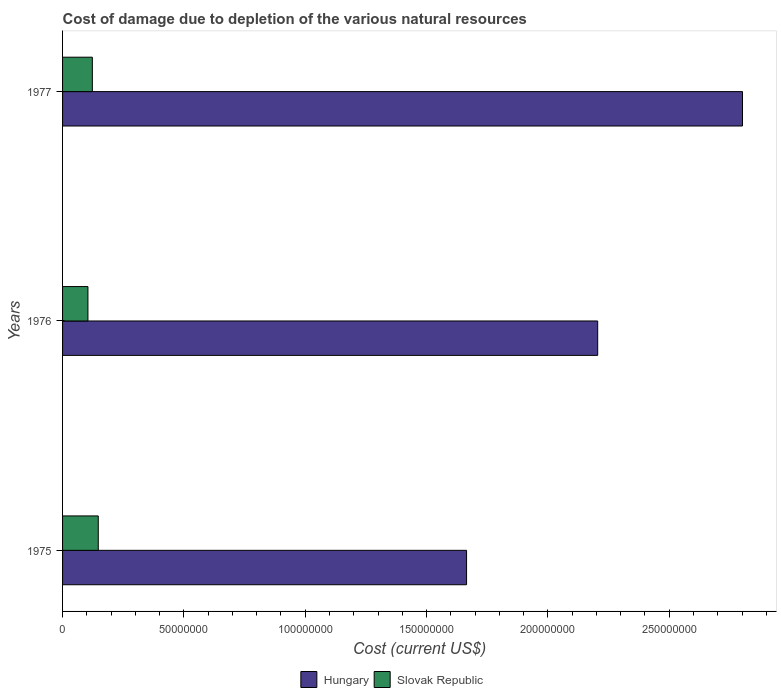How many different coloured bars are there?
Your answer should be very brief. 2. Are the number of bars on each tick of the Y-axis equal?
Keep it short and to the point. Yes. How many bars are there on the 3rd tick from the top?
Your answer should be compact. 2. How many bars are there on the 2nd tick from the bottom?
Keep it short and to the point. 2. What is the label of the 1st group of bars from the top?
Give a very brief answer. 1977. What is the cost of damage caused due to the depletion of various natural resources in Slovak Republic in 1976?
Give a very brief answer. 1.05e+07. Across all years, what is the maximum cost of damage caused due to the depletion of various natural resources in Slovak Republic?
Keep it short and to the point. 1.47e+07. Across all years, what is the minimum cost of damage caused due to the depletion of various natural resources in Hungary?
Your response must be concise. 1.66e+08. In which year was the cost of damage caused due to the depletion of various natural resources in Slovak Republic maximum?
Provide a short and direct response. 1975. In which year was the cost of damage caused due to the depletion of various natural resources in Hungary minimum?
Your answer should be compact. 1975. What is the total cost of damage caused due to the depletion of various natural resources in Slovak Republic in the graph?
Offer a terse response. 3.74e+07. What is the difference between the cost of damage caused due to the depletion of various natural resources in Slovak Republic in 1975 and that in 1976?
Keep it short and to the point. 4.25e+06. What is the difference between the cost of damage caused due to the depletion of various natural resources in Hungary in 1975 and the cost of damage caused due to the depletion of various natural resources in Slovak Republic in 1976?
Make the answer very short. 1.56e+08. What is the average cost of damage caused due to the depletion of various natural resources in Hungary per year?
Ensure brevity in your answer.  2.22e+08. In the year 1977, what is the difference between the cost of damage caused due to the depletion of various natural resources in Hungary and cost of damage caused due to the depletion of various natural resources in Slovak Republic?
Offer a terse response. 2.68e+08. In how many years, is the cost of damage caused due to the depletion of various natural resources in Hungary greater than 200000000 US$?
Your answer should be compact. 2. What is the ratio of the cost of damage caused due to the depletion of various natural resources in Hungary in 1975 to that in 1977?
Give a very brief answer. 0.59. Is the difference between the cost of damage caused due to the depletion of various natural resources in Hungary in 1975 and 1977 greater than the difference between the cost of damage caused due to the depletion of various natural resources in Slovak Republic in 1975 and 1977?
Ensure brevity in your answer.  No. What is the difference between the highest and the second highest cost of damage caused due to the depletion of various natural resources in Hungary?
Offer a very short reply. 5.97e+07. What is the difference between the highest and the lowest cost of damage caused due to the depletion of various natural resources in Hungary?
Offer a very short reply. 1.14e+08. In how many years, is the cost of damage caused due to the depletion of various natural resources in Slovak Republic greater than the average cost of damage caused due to the depletion of various natural resources in Slovak Republic taken over all years?
Give a very brief answer. 1. What does the 1st bar from the top in 1976 represents?
Make the answer very short. Slovak Republic. What does the 1st bar from the bottom in 1975 represents?
Give a very brief answer. Hungary. How many years are there in the graph?
Offer a terse response. 3. Are the values on the major ticks of X-axis written in scientific E-notation?
Ensure brevity in your answer.  No. How many legend labels are there?
Offer a terse response. 2. What is the title of the graph?
Keep it short and to the point. Cost of damage due to depletion of the various natural resources. What is the label or title of the X-axis?
Your response must be concise. Cost (current US$). What is the Cost (current US$) of Hungary in 1975?
Your answer should be very brief. 1.66e+08. What is the Cost (current US$) in Slovak Republic in 1975?
Offer a very short reply. 1.47e+07. What is the Cost (current US$) in Hungary in 1976?
Your response must be concise. 2.21e+08. What is the Cost (current US$) of Slovak Republic in 1976?
Give a very brief answer. 1.05e+07. What is the Cost (current US$) of Hungary in 1977?
Offer a terse response. 2.80e+08. What is the Cost (current US$) of Slovak Republic in 1977?
Provide a succinct answer. 1.23e+07. Across all years, what is the maximum Cost (current US$) in Hungary?
Your response must be concise. 2.80e+08. Across all years, what is the maximum Cost (current US$) in Slovak Republic?
Your response must be concise. 1.47e+07. Across all years, what is the minimum Cost (current US$) of Hungary?
Keep it short and to the point. 1.66e+08. Across all years, what is the minimum Cost (current US$) in Slovak Republic?
Keep it short and to the point. 1.05e+07. What is the total Cost (current US$) in Hungary in the graph?
Your answer should be very brief. 6.67e+08. What is the total Cost (current US$) of Slovak Republic in the graph?
Provide a short and direct response. 3.74e+07. What is the difference between the Cost (current US$) of Hungary in 1975 and that in 1976?
Keep it short and to the point. -5.40e+07. What is the difference between the Cost (current US$) of Slovak Republic in 1975 and that in 1976?
Provide a succinct answer. 4.25e+06. What is the difference between the Cost (current US$) in Hungary in 1975 and that in 1977?
Your answer should be compact. -1.14e+08. What is the difference between the Cost (current US$) in Slovak Republic in 1975 and that in 1977?
Offer a very short reply. 2.44e+06. What is the difference between the Cost (current US$) in Hungary in 1976 and that in 1977?
Ensure brevity in your answer.  -5.97e+07. What is the difference between the Cost (current US$) in Slovak Republic in 1976 and that in 1977?
Provide a short and direct response. -1.81e+06. What is the difference between the Cost (current US$) of Hungary in 1975 and the Cost (current US$) of Slovak Republic in 1976?
Your answer should be very brief. 1.56e+08. What is the difference between the Cost (current US$) of Hungary in 1975 and the Cost (current US$) of Slovak Republic in 1977?
Keep it short and to the point. 1.54e+08. What is the difference between the Cost (current US$) of Hungary in 1976 and the Cost (current US$) of Slovak Republic in 1977?
Offer a very short reply. 2.08e+08. What is the average Cost (current US$) in Hungary per year?
Make the answer very short. 2.22e+08. What is the average Cost (current US$) of Slovak Republic per year?
Your response must be concise. 1.25e+07. In the year 1975, what is the difference between the Cost (current US$) of Hungary and Cost (current US$) of Slovak Republic?
Keep it short and to the point. 1.52e+08. In the year 1976, what is the difference between the Cost (current US$) in Hungary and Cost (current US$) in Slovak Republic?
Your answer should be compact. 2.10e+08. In the year 1977, what is the difference between the Cost (current US$) in Hungary and Cost (current US$) in Slovak Republic?
Your answer should be compact. 2.68e+08. What is the ratio of the Cost (current US$) of Hungary in 1975 to that in 1976?
Provide a short and direct response. 0.75. What is the ratio of the Cost (current US$) in Slovak Republic in 1975 to that in 1976?
Provide a short and direct response. 1.41. What is the ratio of the Cost (current US$) of Hungary in 1975 to that in 1977?
Keep it short and to the point. 0.59. What is the ratio of the Cost (current US$) of Slovak Republic in 1975 to that in 1977?
Keep it short and to the point. 1.2. What is the ratio of the Cost (current US$) of Hungary in 1976 to that in 1977?
Keep it short and to the point. 0.79. What is the ratio of the Cost (current US$) of Slovak Republic in 1976 to that in 1977?
Offer a terse response. 0.85. What is the difference between the highest and the second highest Cost (current US$) of Hungary?
Make the answer very short. 5.97e+07. What is the difference between the highest and the second highest Cost (current US$) in Slovak Republic?
Offer a very short reply. 2.44e+06. What is the difference between the highest and the lowest Cost (current US$) in Hungary?
Provide a short and direct response. 1.14e+08. What is the difference between the highest and the lowest Cost (current US$) in Slovak Republic?
Your answer should be compact. 4.25e+06. 